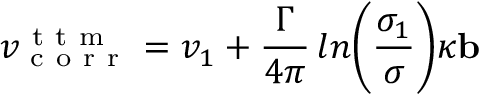Convert formula to latex. <formula><loc_0><loc_0><loc_500><loc_500>v _ { c o r r } ^ { t t m } = v _ { 1 } + \frac { \Gamma } { 4 \pi } \, \ln \left ( \frac { \sigma _ { 1 } } { \sigma } \right ) \kappa b</formula> 